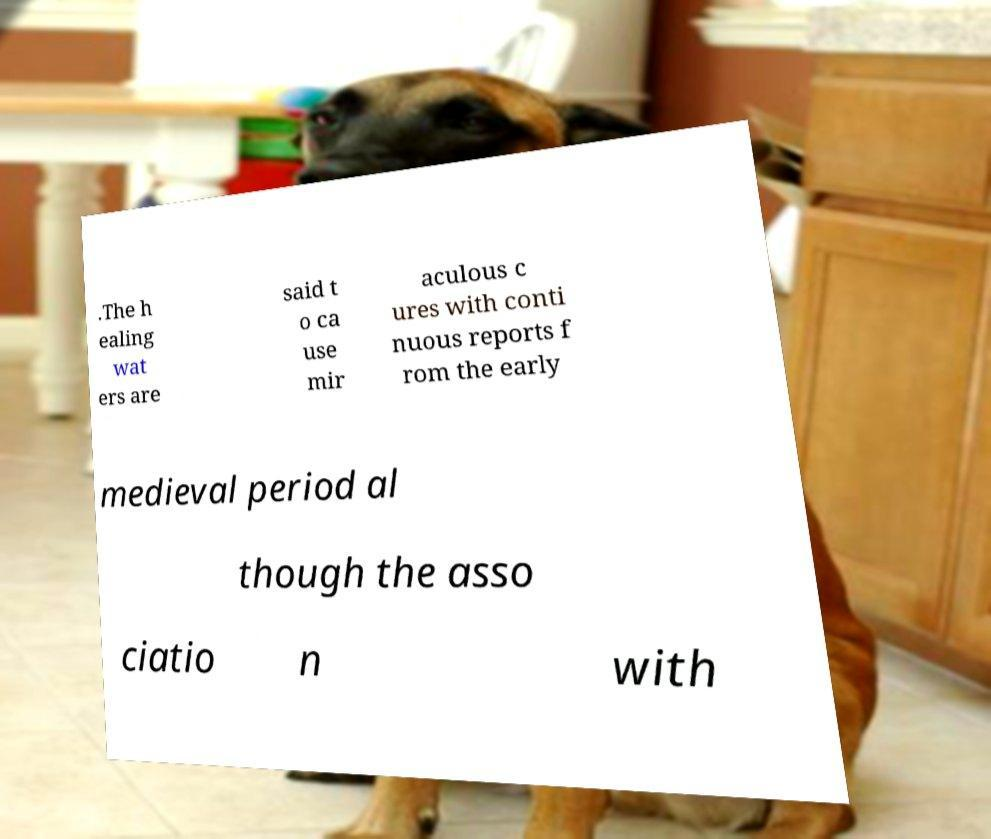Please read and relay the text visible in this image. What does it say? .The h ealing wat ers are said t o ca use mir aculous c ures with conti nuous reports f rom the early medieval period al though the asso ciatio n with 